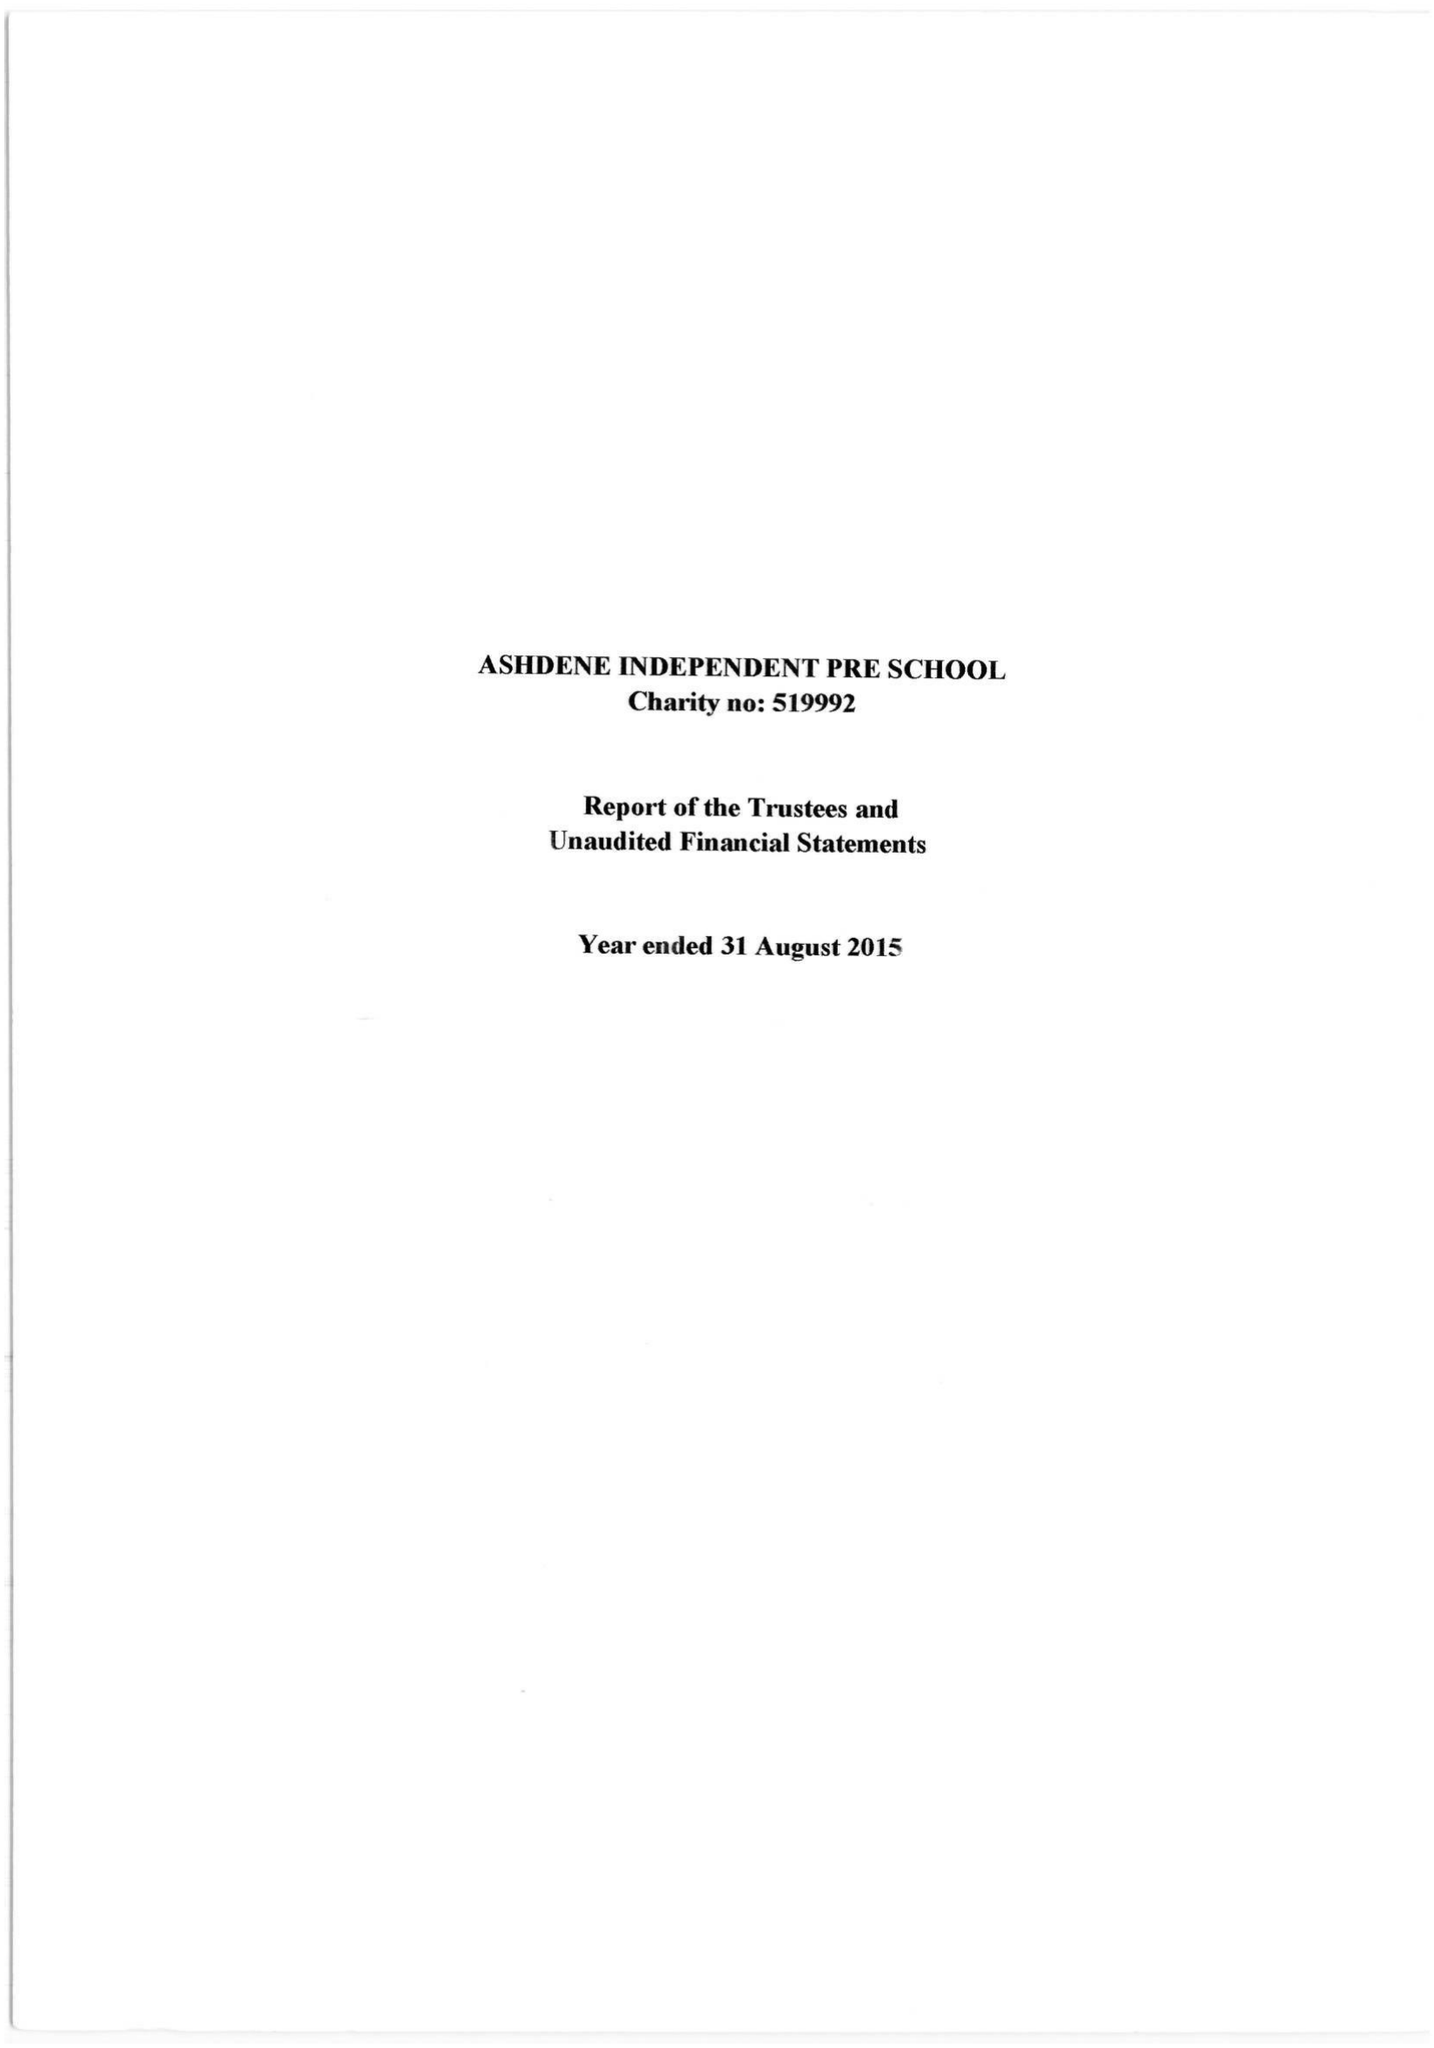What is the value for the address__post_town?
Answer the question using a single word or phrase. None 